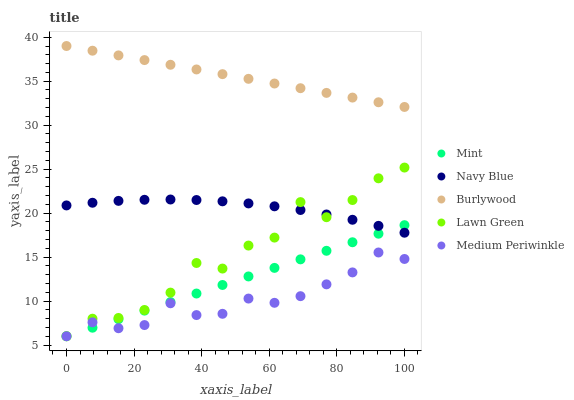Does Medium Periwinkle have the minimum area under the curve?
Answer yes or no. Yes. Does Burlywood have the maximum area under the curve?
Answer yes or no. Yes. Does Navy Blue have the minimum area under the curve?
Answer yes or no. No. Does Navy Blue have the maximum area under the curve?
Answer yes or no. No. Is Mint the smoothest?
Answer yes or no. Yes. Is Lawn Green the roughest?
Answer yes or no. Yes. Is Navy Blue the smoothest?
Answer yes or no. No. Is Navy Blue the roughest?
Answer yes or no. No. Does Mint have the lowest value?
Answer yes or no. Yes. Does Navy Blue have the lowest value?
Answer yes or no. No. Does Burlywood have the highest value?
Answer yes or no. Yes. Does Navy Blue have the highest value?
Answer yes or no. No. Is Medium Periwinkle less than Navy Blue?
Answer yes or no. Yes. Is Burlywood greater than Mint?
Answer yes or no. Yes. Does Mint intersect Lawn Green?
Answer yes or no. Yes. Is Mint less than Lawn Green?
Answer yes or no. No. Is Mint greater than Lawn Green?
Answer yes or no. No. Does Medium Periwinkle intersect Navy Blue?
Answer yes or no. No. 